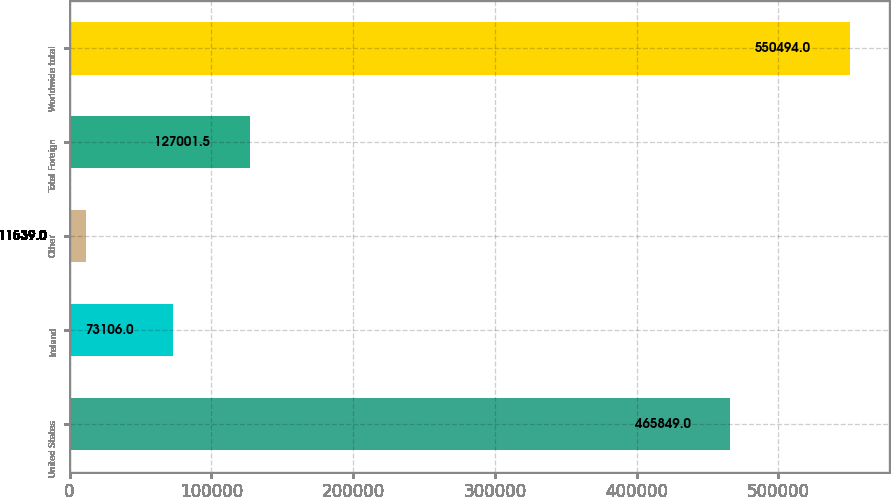Convert chart. <chart><loc_0><loc_0><loc_500><loc_500><bar_chart><fcel>United States<fcel>Ireland<fcel>Other<fcel>Total Foreign<fcel>Worldwide total<nl><fcel>465849<fcel>73106<fcel>11539<fcel>127002<fcel>550494<nl></chart> 